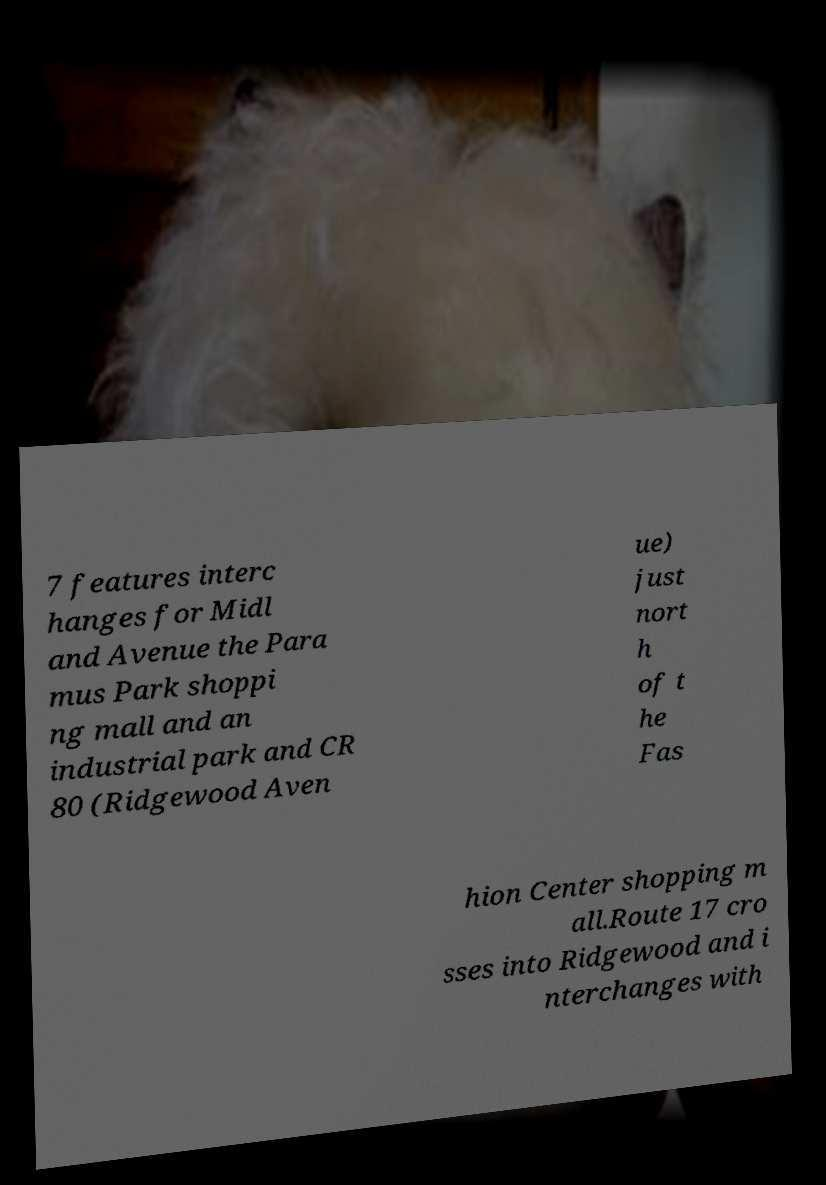Could you extract and type out the text from this image? 7 features interc hanges for Midl and Avenue the Para mus Park shoppi ng mall and an industrial park and CR 80 (Ridgewood Aven ue) just nort h of t he Fas hion Center shopping m all.Route 17 cro sses into Ridgewood and i nterchanges with 